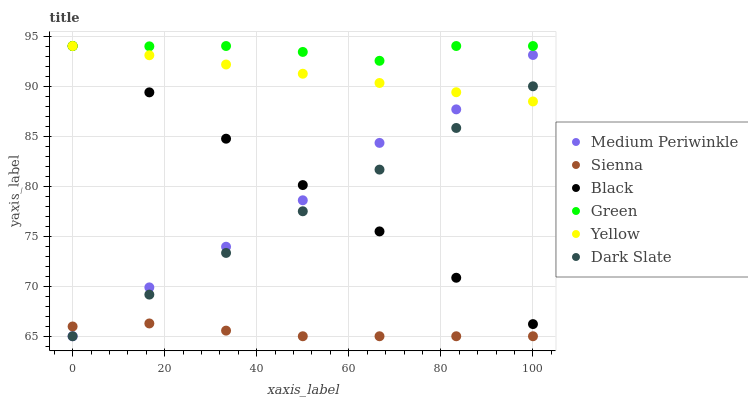Does Sienna have the minimum area under the curve?
Answer yes or no. Yes. Does Green have the maximum area under the curve?
Answer yes or no. Yes. Does Yellow have the minimum area under the curve?
Answer yes or no. No. Does Yellow have the maximum area under the curve?
Answer yes or no. No. Is Yellow the smoothest?
Answer yes or no. Yes. Is Medium Periwinkle the roughest?
Answer yes or no. Yes. Is Sienna the smoothest?
Answer yes or no. No. Is Sienna the roughest?
Answer yes or no. No. Does Medium Periwinkle have the lowest value?
Answer yes or no. Yes. Does Yellow have the lowest value?
Answer yes or no. No. Does Green have the highest value?
Answer yes or no. Yes. Does Sienna have the highest value?
Answer yes or no. No. Is Sienna less than Green?
Answer yes or no. Yes. Is Green greater than Medium Periwinkle?
Answer yes or no. Yes. Does Sienna intersect Dark Slate?
Answer yes or no. Yes. Is Sienna less than Dark Slate?
Answer yes or no. No. Is Sienna greater than Dark Slate?
Answer yes or no. No. Does Sienna intersect Green?
Answer yes or no. No. 